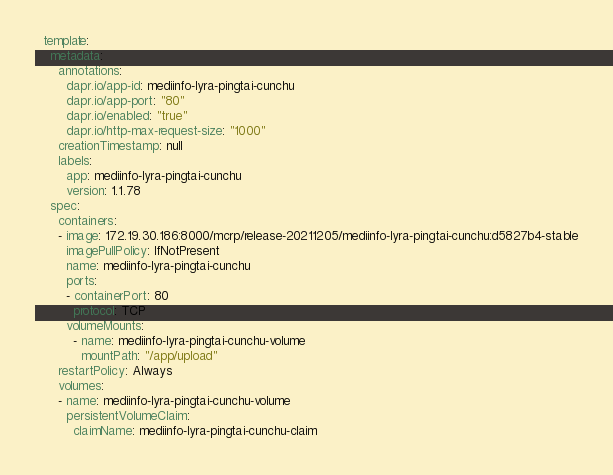<code> <loc_0><loc_0><loc_500><loc_500><_YAML_>  template:
    metadata:
      annotations:
        dapr.io/app-id: mediinfo-lyra-pingtai-cunchu
        dapr.io/app-port: "80"
        dapr.io/enabled: "true"
        dapr.io/http-max-request-size: "1000"
      creationTimestamp: null
      labels:
        app: mediinfo-lyra-pingtai-cunchu
        version: 1.1.78
    spec:
      containers:
      - image: 172.19.30.186:8000/mcrp/release-20211205/mediinfo-lyra-pingtai-cunchu:d5827b4-stable
        imagePullPolicy: IfNotPresent
        name: mediinfo-lyra-pingtai-cunchu
        ports:
        - containerPort: 80
          protocol: TCP
        volumeMounts: 
          - name: mediinfo-lyra-pingtai-cunchu-volume
            mountPath: "/app/upload"
      restartPolicy: Always
      volumes: 
      - name: mediinfo-lyra-pingtai-cunchu-volume
        persistentVolumeClaim:
          claimName: mediinfo-lyra-pingtai-cunchu-claim
</code> 